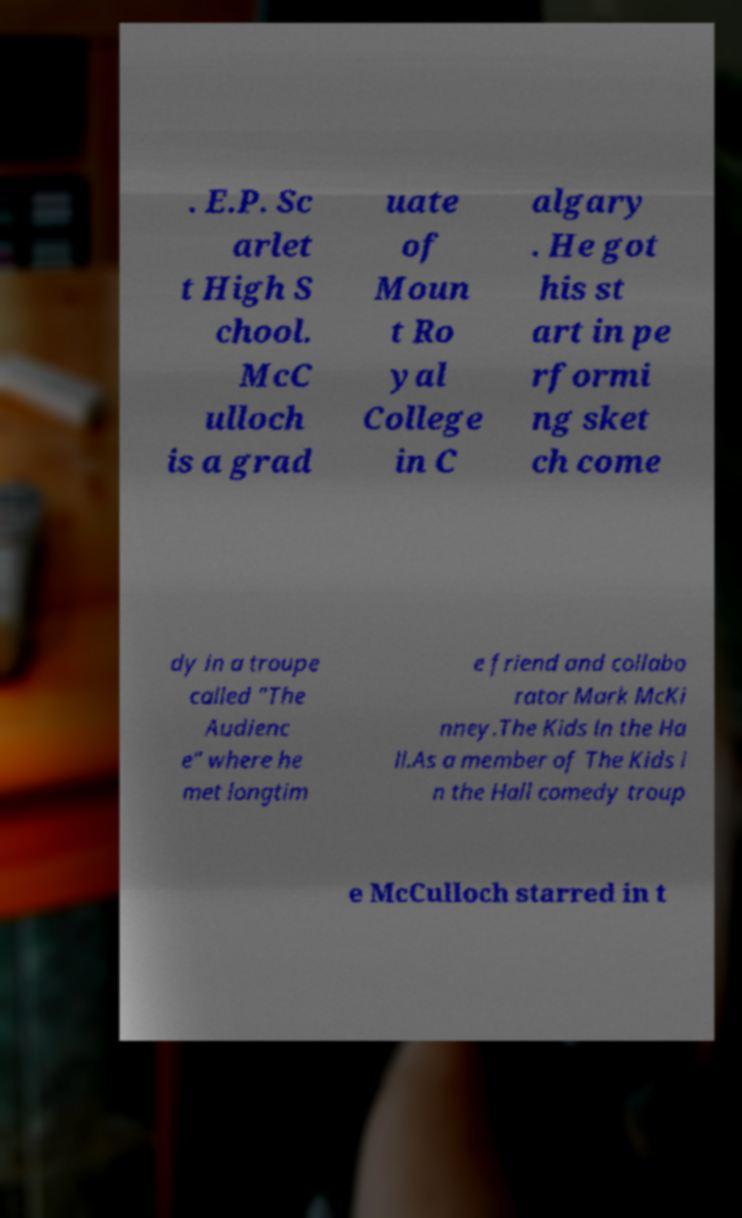I need the written content from this picture converted into text. Can you do that? . E.P. Sc arlet t High S chool. McC ulloch is a grad uate of Moun t Ro yal College in C algary . He got his st art in pe rformi ng sket ch come dy in a troupe called "The Audienc e" where he met longtim e friend and collabo rator Mark McKi nney.The Kids in the Ha ll.As a member of The Kids i n the Hall comedy troup e McCulloch starred in t 